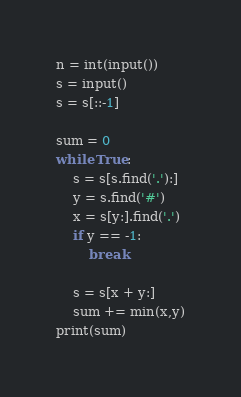Convert code to text. <code><loc_0><loc_0><loc_500><loc_500><_Python_>
n = int(input())
s = input()
s = s[::-1]

sum = 0
while True:
    s = s[s.find('.'):]
    y = s.find('#')
    x = s[y:].find('.')
    if y == -1:
        break

    s = s[x + y:]
    sum += min(x,y)
print(sum)</code> 